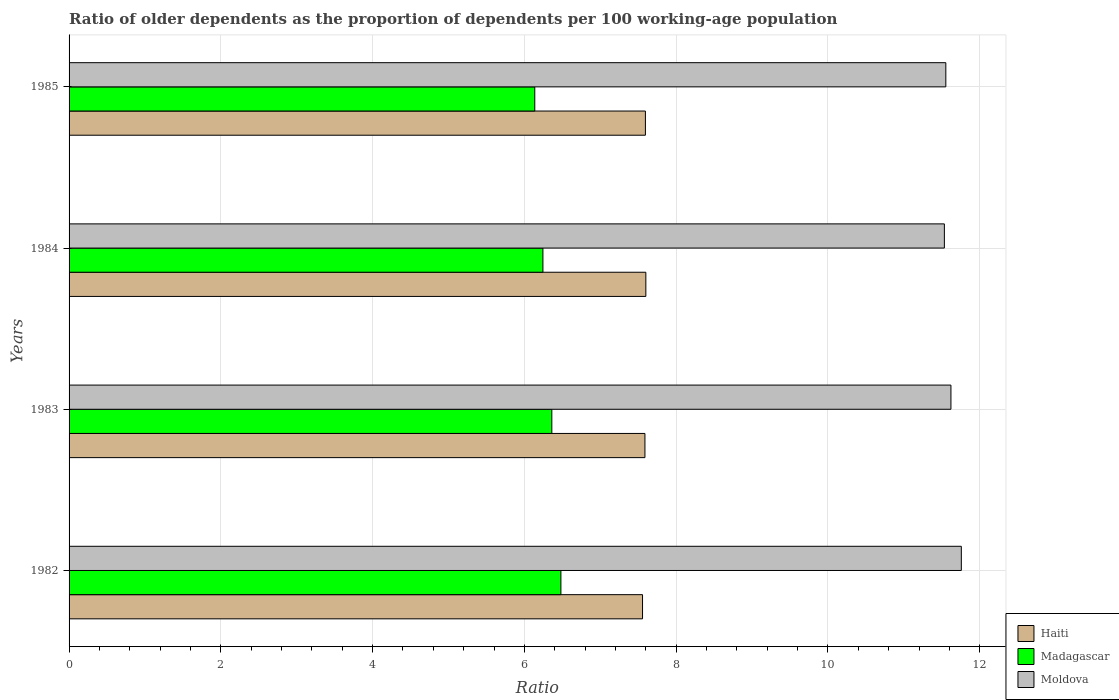How many different coloured bars are there?
Keep it short and to the point. 3. How many groups of bars are there?
Your response must be concise. 4. What is the age dependency ratio(old) in Haiti in 1984?
Provide a short and direct response. 7.6. Across all years, what is the maximum age dependency ratio(old) in Moldova?
Ensure brevity in your answer.  11.76. Across all years, what is the minimum age dependency ratio(old) in Haiti?
Your answer should be compact. 7.56. In which year was the age dependency ratio(old) in Haiti minimum?
Keep it short and to the point. 1982. What is the total age dependency ratio(old) in Moldova in the graph?
Provide a short and direct response. 46.47. What is the difference between the age dependency ratio(old) in Madagascar in 1983 and that in 1984?
Make the answer very short. 0.12. What is the difference between the age dependency ratio(old) in Moldova in 1983 and the age dependency ratio(old) in Haiti in 1984?
Make the answer very short. 4.02. What is the average age dependency ratio(old) in Moldova per year?
Make the answer very short. 11.62. In the year 1985, what is the difference between the age dependency ratio(old) in Madagascar and age dependency ratio(old) in Haiti?
Your response must be concise. -1.46. In how many years, is the age dependency ratio(old) in Madagascar greater than 11.2 ?
Your answer should be very brief. 0. What is the ratio of the age dependency ratio(old) in Moldova in 1984 to that in 1985?
Keep it short and to the point. 1. Is the difference between the age dependency ratio(old) in Madagascar in 1982 and 1985 greater than the difference between the age dependency ratio(old) in Haiti in 1982 and 1985?
Offer a very short reply. Yes. What is the difference between the highest and the second highest age dependency ratio(old) in Madagascar?
Give a very brief answer. 0.12. What is the difference between the highest and the lowest age dependency ratio(old) in Madagascar?
Offer a terse response. 0.34. In how many years, is the age dependency ratio(old) in Moldova greater than the average age dependency ratio(old) in Moldova taken over all years?
Your answer should be compact. 2. Is the sum of the age dependency ratio(old) in Haiti in 1982 and 1985 greater than the maximum age dependency ratio(old) in Moldova across all years?
Keep it short and to the point. Yes. What does the 2nd bar from the top in 1983 represents?
Provide a short and direct response. Madagascar. What does the 1st bar from the bottom in 1982 represents?
Your answer should be very brief. Haiti. How many bars are there?
Offer a very short reply. 12. What is the difference between two consecutive major ticks on the X-axis?
Your response must be concise. 2. Does the graph contain grids?
Make the answer very short. Yes. How many legend labels are there?
Offer a terse response. 3. What is the title of the graph?
Keep it short and to the point. Ratio of older dependents as the proportion of dependents per 100 working-age population. Does "Chile" appear as one of the legend labels in the graph?
Provide a short and direct response. No. What is the label or title of the X-axis?
Keep it short and to the point. Ratio. What is the Ratio in Haiti in 1982?
Keep it short and to the point. 7.56. What is the Ratio of Madagascar in 1982?
Offer a very short reply. 6.48. What is the Ratio of Moldova in 1982?
Offer a terse response. 11.76. What is the Ratio of Haiti in 1983?
Ensure brevity in your answer.  7.59. What is the Ratio of Madagascar in 1983?
Your response must be concise. 6.36. What is the Ratio in Moldova in 1983?
Offer a very short reply. 11.62. What is the Ratio of Haiti in 1984?
Your response must be concise. 7.6. What is the Ratio in Madagascar in 1984?
Provide a succinct answer. 6.24. What is the Ratio of Moldova in 1984?
Your answer should be compact. 11.53. What is the Ratio of Haiti in 1985?
Provide a short and direct response. 7.59. What is the Ratio of Madagascar in 1985?
Make the answer very short. 6.14. What is the Ratio of Moldova in 1985?
Your response must be concise. 11.55. Across all years, what is the maximum Ratio in Haiti?
Make the answer very short. 7.6. Across all years, what is the maximum Ratio of Madagascar?
Keep it short and to the point. 6.48. Across all years, what is the maximum Ratio of Moldova?
Your response must be concise. 11.76. Across all years, what is the minimum Ratio in Haiti?
Offer a very short reply. 7.56. Across all years, what is the minimum Ratio in Madagascar?
Provide a short and direct response. 6.14. Across all years, what is the minimum Ratio in Moldova?
Your answer should be compact. 11.53. What is the total Ratio of Haiti in the graph?
Keep it short and to the point. 30.34. What is the total Ratio in Madagascar in the graph?
Provide a short and direct response. 25.22. What is the total Ratio in Moldova in the graph?
Make the answer very short. 46.47. What is the difference between the Ratio of Haiti in 1982 and that in 1983?
Give a very brief answer. -0.03. What is the difference between the Ratio of Madagascar in 1982 and that in 1983?
Provide a short and direct response. 0.12. What is the difference between the Ratio of Moldova in 1982 and that in 1983?
Provide a succinct answer. 0.14. What is the difference between the Ratio in Haiti in 1982 and that in 1984?
Provide a short and direct response. -0.04. What is the difference between the Ratio in Madagascar in 1982 and that in 1984?
Offer a terse response. 0.24. What is the difference between the Ratio of Moldova in 1982 and that in 1984?
Keep it short and to the point. 0.22. What is the difference between the Ratio in Haiti in 1982 and that in 1985?
Keep it short and to the point. -0.04. What is the difference between the Ratio of Madagascar in 1982 and that in 1985?
Offer a very short reply. 0.34. What is the difference between the Ratio of Moldova in 1982 and that in 1985?
Your answer should be very brief. 0.2. What is the difference between the Ratio of Haiti in 1983 and that in 1984?
Keep it short and to the point. -0.01. What is the difference between the Ratio in Madagascar in 1983 and that in 1984?
Provide a short and direct response. 0.12. What is the difference between the Ratio in Moldova in 1983 and that in 1984?
Your answer should be compact. 0.09. What is the difference between the Ratio in Haiti in 1983 and that in 1985?
Your response must be concise. -0.01. What is the difference between the Ratio in Madagascar in 1983 and that in 1985?
Your answer should be very brief. 0.22. What is the difference between the Ratio of Moldova in 1983 and that in 1985?
Give a very brief answer. 0.07. What is the difference between the Ratio of Haiti in 1984 and that in 1985?
Make the answer very short. 0.01. What is the difference between the Ratio of Madagascar in 1984 and that in 1985?
Offer a terse response. 0.11. What is the difference between the Ratio in Moldova in 1984 and that in 1985?
Your answer should be compact. -0.02. What is the difference between the Ratio of Haiti in 1982 and the Ratio of Madagascar in 1983?
Keep it short and to the point. 1.2. What is the difference between the Ratio of Haiti in 1982 and the Ratio of Moldova in 1983?
Provide a short and direct response. -4.06. What is the difference between the Ratio in Madagascar in 1982 and the Ratio in Moldova in 1983?
Provide a succinct answer. -5.14. What is the difference between the Ratio of Haiti in 1982 and the Ratio of Madagascar in 1984?
Ensure brevity in your answer.  1.31. What is the difference between the Ratio of Haiti in 1982 and the Ratio of Moldova in 1984?
Provide a short and direct response. -3.98. What is the difference between the Ratio of Madagascar in 1982 and the Ratio of Moldova in 1984?
Offer a very short reply. -5.05. What is the difference between the Ratio in Haiti in 1982 and the Ratio in Madagascar in 1985?
Your answer should be compact. 1.42. What is the difference between the Ratio of Haiti in 1982 and the Ratio of Moldova in 1985?
Your answer should be very brief. -4. What is the difference between the Ratio in Madagascar in 1982 and the Ratio in Moldova in 1985?
Your answer should be compact. -5.07. What is the difference between the Ratio in Haiti in 1983 and the Ratio in Madagascar in 1984?
Keep it short and to the point. 1.34. What is the difference between the Ratio of Haiti in 1983 and the Ratio of Moldova in 1984?
Keep it short and to the point. -3.95. What is the difference between the Ratio in Madagascar in 1983 and the Ratio in Moldova in 1984?
Provide a short and direct response. -5.17. What is the difference between the Ratio in Haiti in 1983 and the Ratio in Madagascar in 1985?
Make the answer very short. 1.45. What is the difference between the Ratio in Haiti in 1983 and the Ratio in Moldova in 1985?
Your answer should be compact. -3.96. What is the difference between the Ratio of Madagascar in 1983 and the Ratio of Moldova in 1985?
Provide a succinct answer. -5.19. What is the difference between the Ratio in Haiti in 1984 and the Ratio in Madagascar in 1985?
Give a very brief answer. 1.46. What is the difference between the Ratio in Haiti in 1984 and the Ratio in Moldova in 1985?
Your answer should be very brief. -3.95. What is the difference between the Ratio of Madagascar in 1984 and the Ratio of Moldova in 1985?
Provide a short and direct response. -5.31. What is the average Ratio in Haiti per year?
Ensure brevity in your answer.  7.58. What is the average Ratio of Madagascar per year?
Offer a terse response. 6.31. What is the average Ratio of Moldova per year?
Keep it short and to the point. 11.62. In the year 1982, what is the difference between the Ratio in Haiti and Ratio in Madagascar?
Offer a terse response. 1.08. In the year 1982, what is the difference between the Ratio in Haiti and Ratio in Moldova?
Offer a terse response. -4.2. In the year 1982, what is the difference between the Ratio in Madagascar and Ratio in Moldova?
Give a very brief answer. -5.28. In the year 1983, what is the difference between the Ratio in Haiti and Ratio in Madagascar?
Make the answer very short. 1.23. In the year 1983, what is the difference between the Ratio of Haiti and Ratio of Moldova?
Offer a terse response. -4.03. In the year 1983, what is the difference between the Ratio in Madagascar and Ratio in Moldova?
Your answer should be very brief. -5.26. In the year 1984, what is the difference between the Ratio in Haiti and Ratio in Madagascar?
Offer a very short reply. 1.36. In the year 1984, what is the difference between the Ratio in Haiti and Ratio in Moldova?
Your response must be concise. -3.93. In the year 1984, what is the difference between the Ratio of Madagascar and Ratio of Moldova?
Make the answer very short. -5.29. In the year 1985, what is the difference between the Ratio of Haiti and Ratio of Madagascar?
Provide a short and direct response. 1.46. In the year 1985, what is the difference between the Ratio in Haiti and Ratio in Moldova?
Make the answer very short. -3.96. In the year 1985, what is the difference between the Ratio of Madagascar and Ratio of Moldova?
Provide a short and direct response. -5.42. What is the ratio of the Ratio of Madagascar in 1982 to that in 1983?
Keep it short and to the point. 1.02. What is the ratio of the Ratio of Moldova in 1982 to that in 1983?
Keep it short and to the point. 1.01. What is the ratio of the Ratio of Haiti in 1982 to that in 1984?
Offer a very short reply. 0.99. What is the ratio of the Ratio in Madagascar in 1982 to that in 1984?
Your response must be concise. 1.04. What is the ratio of the Ratio of Moldova in 1982 to that in 1984?
Keep it short and to the point. 1.02. What is the ratio of the Ratio of Haiti in 1982 to that in 1985?
Make the answer very short. 0.99. What is the ratio of the Ratio in Madagascar in 1982 to that in 1985?
Provide a short and direct response. 1.06. What is the ratio of the Ratio in Moldova in 1982 to that in 1985?
Offer a very short reply. 1.02. What is the ratio of the Ratio in Haiti in 1983 to that in 1984?
Provide a succinct answer. 1. What is the ratio of the Ratio in Madagascar in 1983 to that in 1984?
Make the answer very short. 1.02. What is the ratio of the Ratio in Moldova in 1983 to that in 1984?
Make the answer very short. 1.01. What is the ratio of the Ratio in Haiti in 1983 to that in 1985?
Provide a succinct answer. 1. What is the ratio of the Ratio of Madagascar in 1983 to that in 1985?
Provide a short and direct response. 1.04. What is the ratio of the Ratio in Moldova in 1983 to that in 1985?
Offer a very short reply. 1.01. What is the ratio of the Ratio in Haiti in 1984 to that in 1985?
Your answer should be very brief. 1. What is the ratio of the Ratio in Madagascar in 1984 to that in 1985?
Your answer should be very brief. 1.02. What is the ratio of the Ratio of Moldova in 1984 to that in 1985?
Your answer should be very brief. 1. What is the difference between the highest and the second highest Ratio of Haiti?
Give a very brief answer. 0.01. What is the difference between the highest and the second highest Ratio in Madagascar?
Ensure brevity in your answer.  0.12. What is the difference between the highest and the second highest Ratio in Moldova?
Offer a very short reply. 0.14. What is the difference between the highest and the lowest Ratio in Haiti?
Offer a terse response. 0.04. What is the difference between the highest and the lowest Ratio of Madagascar?
Offer a very short reply. 0.34. What is the difference between the highest and the lowest Ratio in Moldova?
Ensure brevity in your answer.  0.22. 